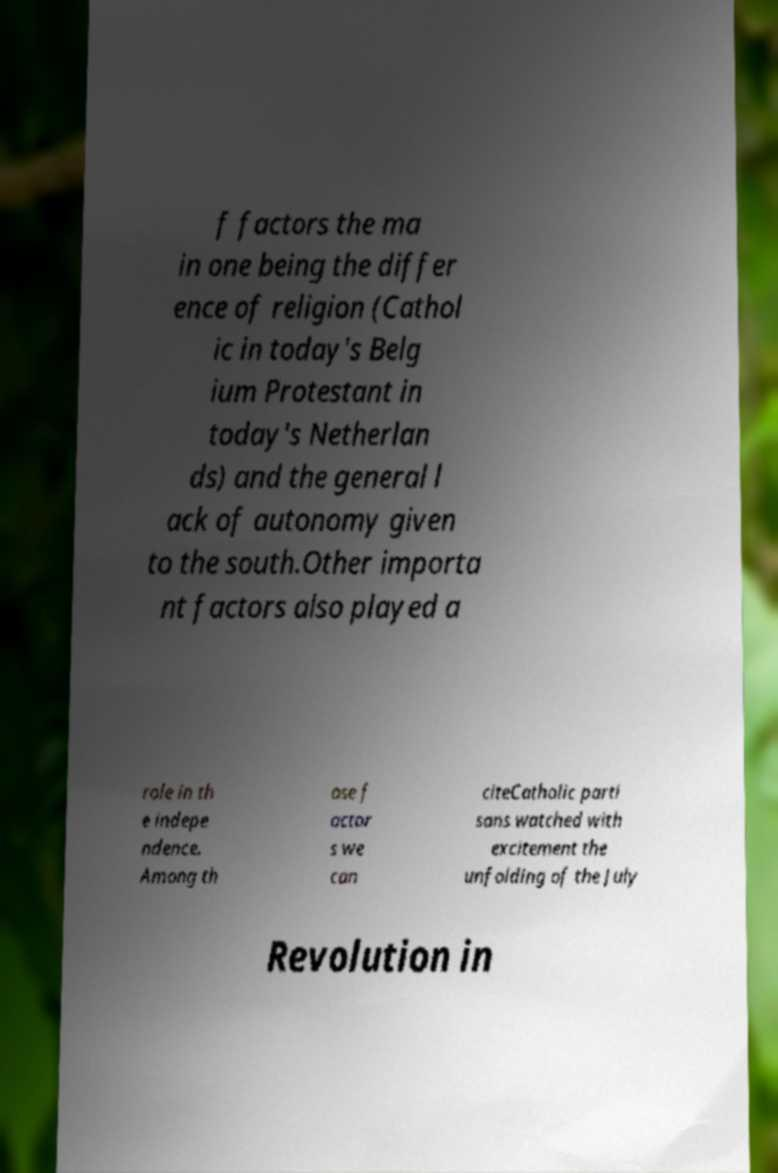What messages or text are displayed in this image? I need them in a readable, typed format. f factors the ma in one being the differ ence of religion (Cathol ic in today's Belg ium Protestant in today's Netherlan ds) and the general l ack of autonomy given to the south.Other importa nt factors also played a role in th e indepe ndence. Among th ose f actor s we can citeCatholic parti sans watched with excitement the unfolding of the July Revolution in 